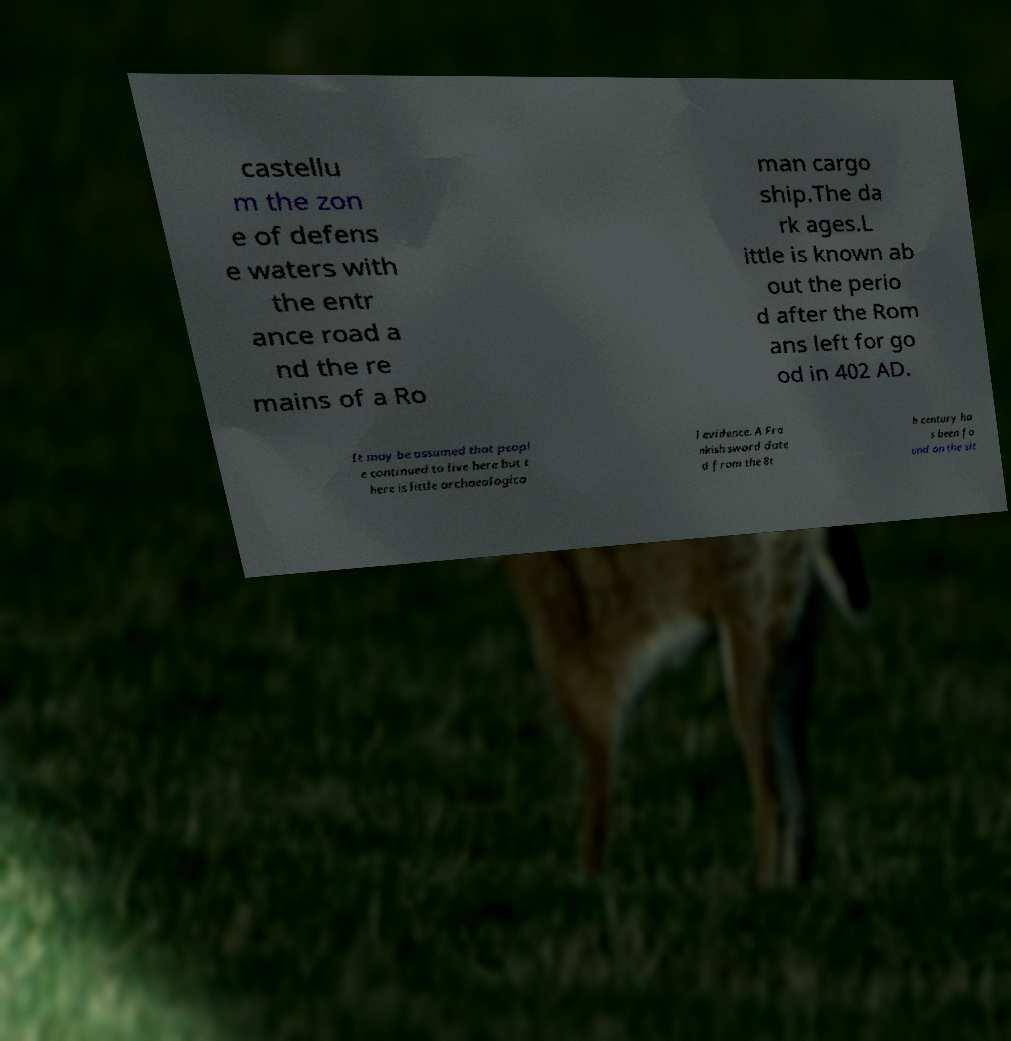Can you read and provide the text displayed in the image?This photo seems to have some interesting text. Can you extract and type it out for me? castellu m the zon e of defens e waters with the entr ance road a nd the re mains of a Ro man cargo ship.The da rk ages.L ittle is known ab out the perio d after the Rom ans left for go od in 402 AD. It may be assumed that peopl e continued to live here but t here is little archaeologica l evidence. A Fra nkish sword date d from the 8t h century ha s been fo und on the sit 